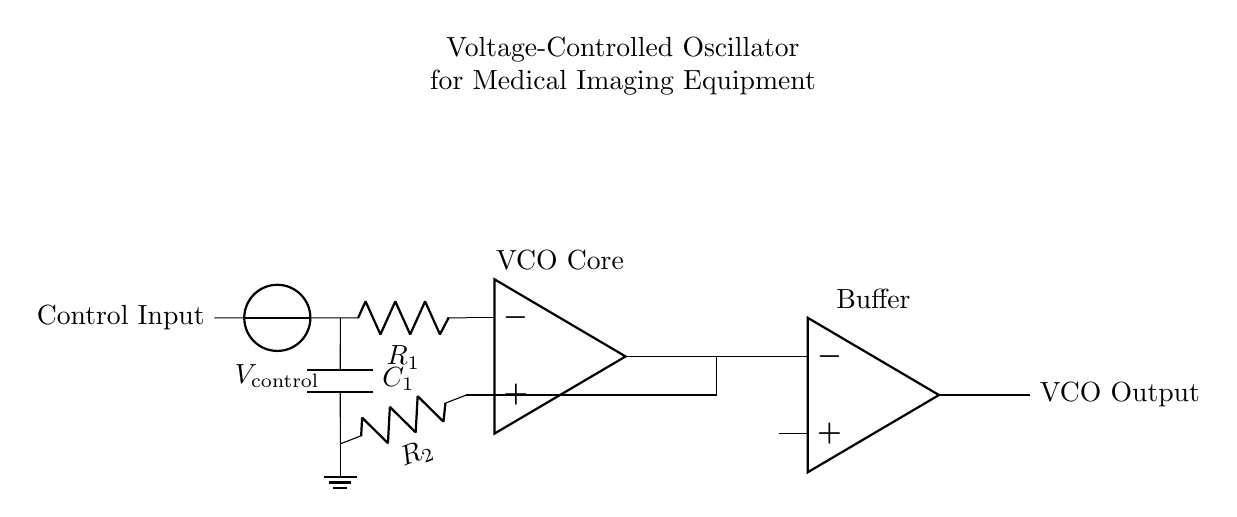What is the type of oscillator depicted in the circuit? The circuit is a voltage-controlled oscillator (VCO), which indicates it adjusts its output frequency based on the control voltage input.
Answer: Voltage-controlled oscillator What components are used in the VCO circuit? The circuit comprises resistors, capacitors, and operational amplifiers, with specific components being R1, R2, C1, and two op amps.
Answer: Resistors, capacitors, operational amplifiers What is the purpose of V_control in this circuit? V_control serves as the control voltage input that determines the frequency of the VCO output, which can be adjusted based on this input.
Answer: Control voltage input How many operational amplifiers are present in this circuit? Upon examining the circuit, there are two operational amplifiers, one in the VCO core and another used as an output buffer.
Answer: Two What role does R2 play in this VCO circuit? R2 is connected to the inverting input of the first op amp and provides feedback, influencing the gain and stability of the oscillator.
Answer: Feedback resistor What would happen if C1 were changed to a larger value? Increasing the capacitance of C1 would generally lower the oscillation frequency of the VCO, as the timing characteristics depend on C1 and R1.
Answer: Lower frequency output 